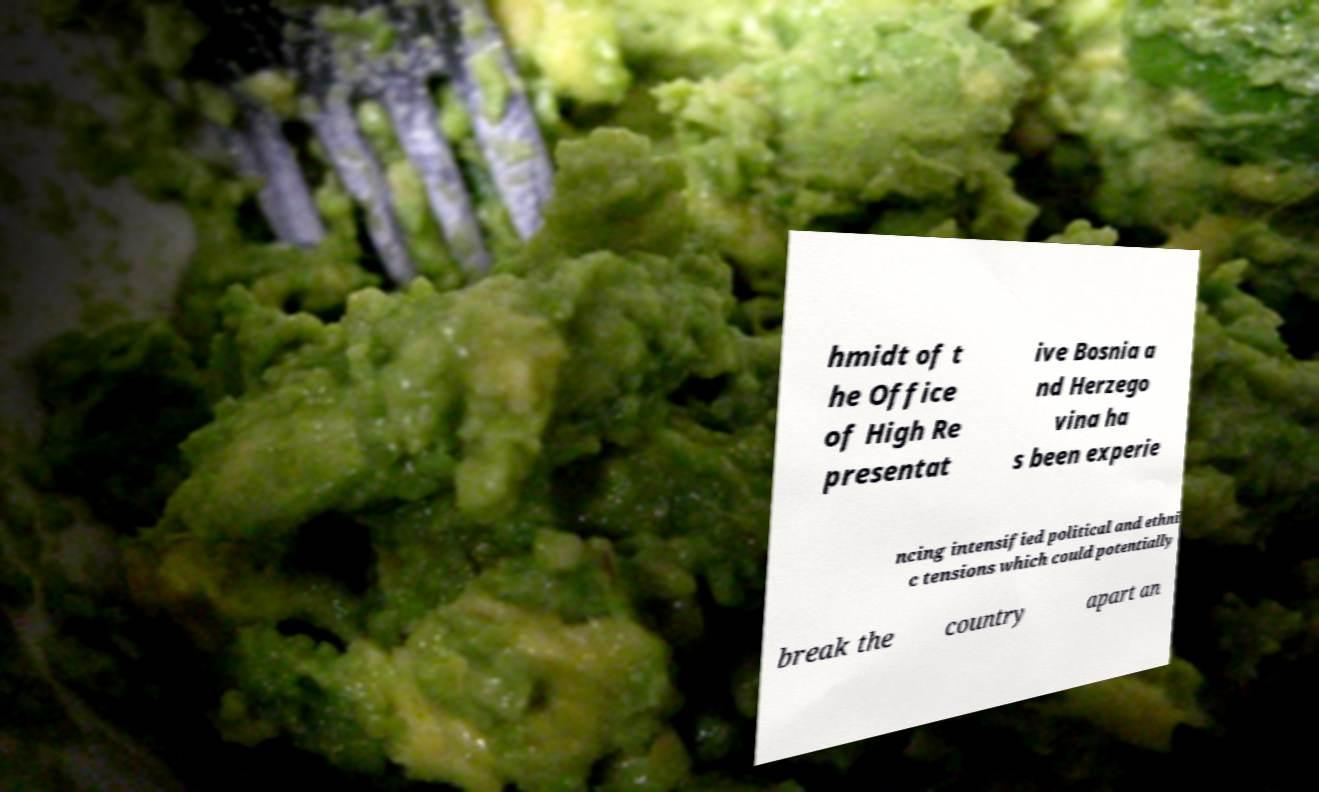Could you assist in decoding the text presented in this image and type it out clearly? hmidt of t he Office of High Re presentat ive Bosnia a nd Herzego vina ha s been experie ncing intensified political and ethni c tensions which could potentially break the country apart an 